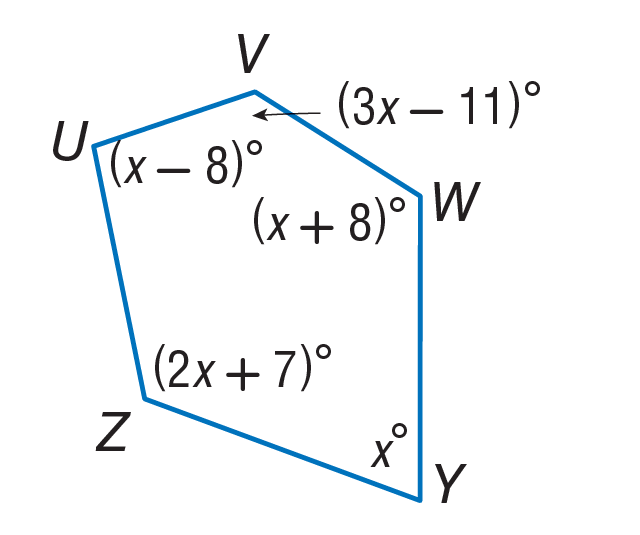Answer the mathemtical geometry problem and directly provide the correct option letter.
Question: Find m \angle Z.
Choices: A: 34 B: 68 C: 136 D: 143 D 